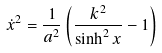Convert formula to latex. <formula><loc_0><loc_0><loc_500><loc_500>\dot { x } ^ { 2 } = \frac { 1 } { a ^ { 2 } } \left ( \frac { k ^ { 2 } } { \sinh ^ { 2 } x } - 1 \right )</formula> 